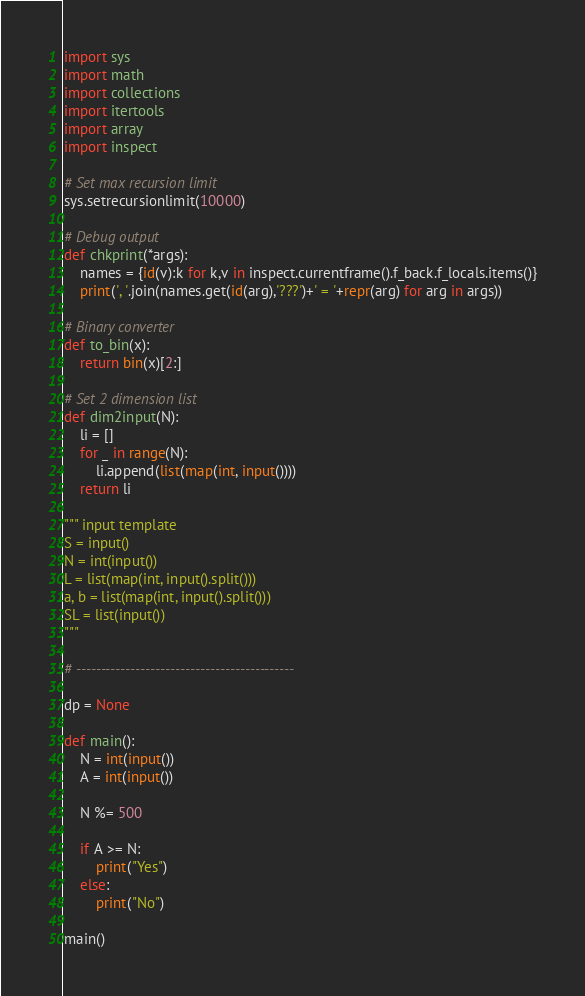<code> <loc_0><loc_0><loc_500><loc_500><_Python_>import sys
import math
import collections
import itertools
import array
import inspect

# Set max recursion limit
sys.setrecursionlimit(10000)

# Debug output
def chkprint(*args):
    names = {id(v):k for k,v in inspect.currentframe().f_back.f_locals.items()}
    print(', '.join(names.get(id(arg),'???')+' = '+repr(arg) for arg in args))

# Binary converter
def to_bin(x):
    return bin(x)[2:]

# Set 2 dimension list
def dim2input(N):
    li = []
    for _ in range(N):
        li.append(list(map(int, input())))
    return li

""" input template
S = input()
N = int(input())
L = list(map(int, input().split()))
a, b = list(map(int, input().split()))
SL = list(input())
"""

# --------------------------------------------

dp = None

def main():
    N = int(input())
    A = int(input())

    N %= 500

    if A >= N:
        print("Yes")
    else:
        print("No")

main()
</code> 